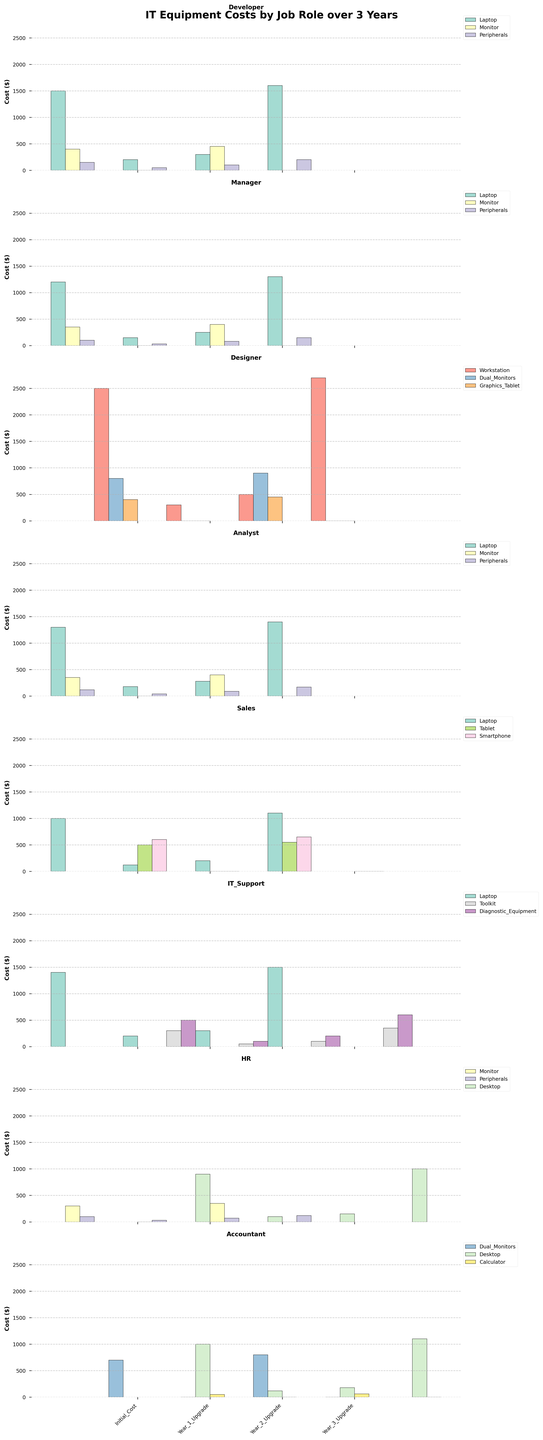Which job role has the highest initial cost for equipment? To determine the job role with the highest initial cost, look at the initial cost values for each job role and identify the maximum value. The Designer job role has the highest initial cost because the workstation costs $2500.
Answer: Designer Which job role spends the most on laptop upgrades over 3 years? Sum the upgrade costs for laptops over Year 1, Year 2, and Year 3 for each relevant job role. Developers spent a total of $2100 (200 + 300 + 1600) and Managers spent $1700. Analysts spent $1860, Sales spent $1420, and IT Support spent $2000. Developers spend the most.
Answer: Developer How much more do Designers spend on graphics tablets in Year 2 compared to Year 1? Subtract the Year 1 upgrade cost from the Year 2 upgrade cost for the graphics tablet. The Year 1 cost is $0, and the Year 2 cost is $450, so the difference is $450 - $0.
Answer: $450 Which job role has the least upgrade cost in Year 1? For each job role, sum the upgrade costs of all equipment types in Year 1 and identify the minimum value. HR, Sales, and Designers all spend $100 in Year 1 on a combination of different equipment.
Answer: HR, Sales, Designer (tie) What's the total cost for an IT Support employee's toolkit and diagnostic equipment upgrades over 3 years? Add up the upgrade costs for toolkit and diagnostic equipment over Year 1, Year 2, and Year 3. Toolkit: $50 + $100 + $350 = $500, Diagnostic Equipment: $100 + $200 + $600 = $900, Total: $500 + $900 = $1400.
Answer: $1400 